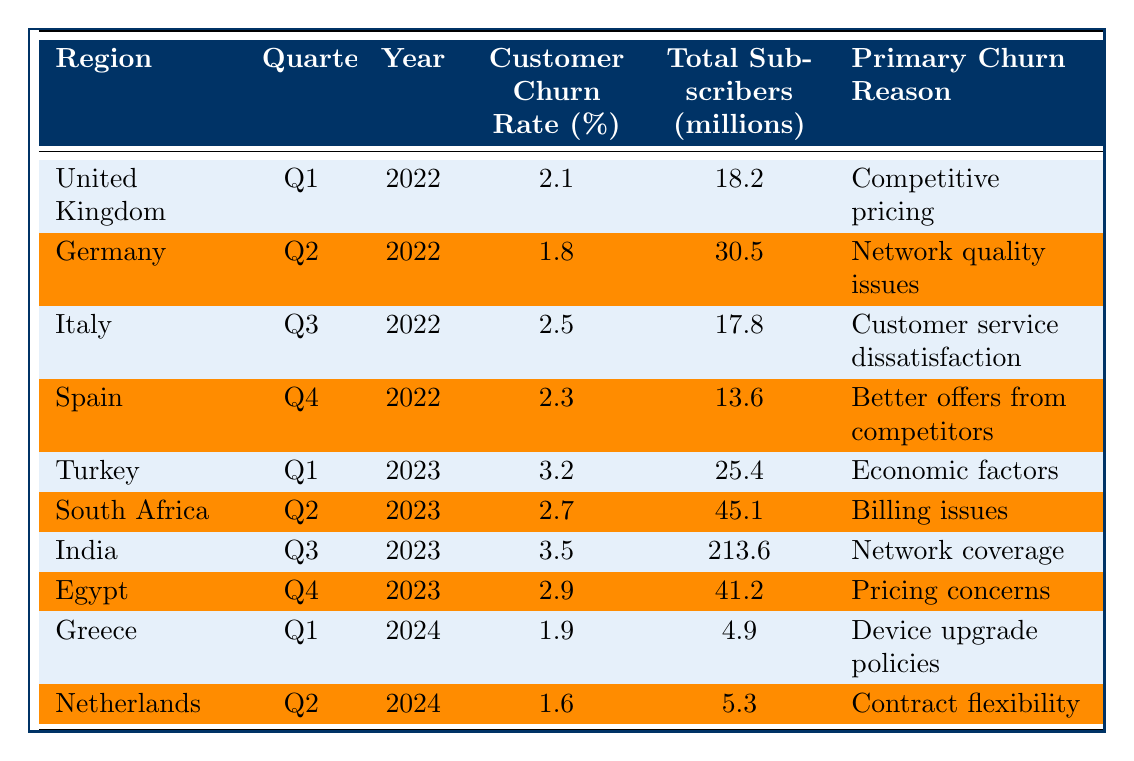What was the customer churn rate in Germany in Q2 2022? The table shows the customer churn rate for Germany in Q2 2022 as 1.8%.
Answer: 1.8% Which region had the highest customer churn rate and what was that rate? The table indicates that India had the highest customer churn rate at 3.5% in Q3 2023.
Answer: 3.5% in India What is the primary churn reason for customers in Turkey for Q1 2023? According to the table, the primary churn reason for customers in Turkey in Q1 2023 is economic factors.
Answer: Economic factors How many total subscribers were there in Italy in Q3 2022? The total number of subscribers in Italy in Q3 2022 is listed as 17.8 million.
Answer: 17.8 million What is the average customer churn rate across all regions for the year 2022? The churn rates for 2022 are 2.1%, 1.8%, 2.5%, and 2.3%. Calculating the average gives (2.1 + 1.8 + 2.5 + 2.3) / 4 = 2.175%.
Answer: 2.175% Did any region have a customer churn rate below 2%? Yes, the table shows that Germany had a churn rate of 1.8%, which is below 2%.
Answer: Yes What was the increase in churn rate from Q4 2022 in Spain to Q1 2023 in Turkey? The churn rate in Spain for Q4 2022 was 2.3% and in Turkey for Q1 2023 it was 3.2%. The increase is 3.2% - 2.3% = 0.9%.
Answer: 0.9% Which region had the least number of total subscribers, and what was that number? Greece had the least number of total subscribers with 4.9 million.
Answer: 4.9 million What are the primary churn reasons for the regions that had a churn rate above 3%? The primary churn reason for Turkey is economic factors (Q1 2023) and for India is network coverage (Q3 2023).
Answer: Economic factors and network coverage How does the customer churn rate in the Netherlands in Q2 2024 compare to that in the United Kingdom in Q1 2022? The churn rate in the Netherlands is 1.6% whereas in the United Kingdom it was 2.1%. therefore, it is lower in the Netherlands by 0.5%.
Answer: Lower by 0.5% 